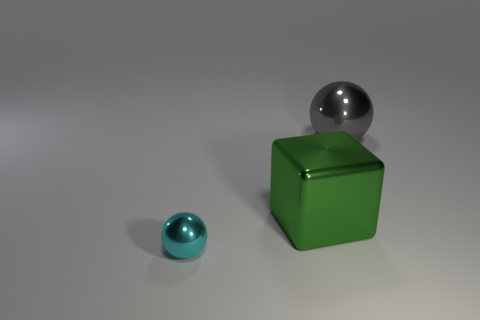Add 2 gray shiny balls. How many objects exist? 5 Subtract all blocks. How many objects are left? 2 Subtract 0 red balls. How many objects are left? 3 Subtract all big gray objects. Subtract all small cyan matte objects. How many objects are left? 2 Add 3 cyan balls. How many cyan balls are left? 4 Add 2 cyan things. How many cyan things exist? 3 